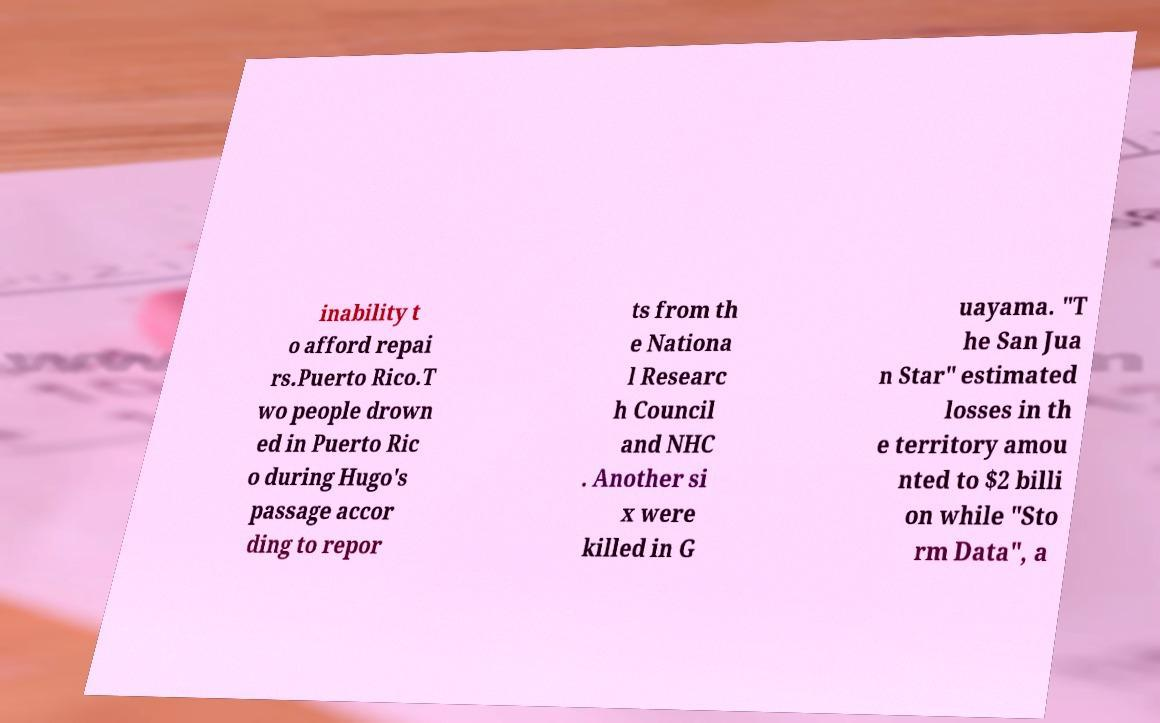Please read and relay the text visible in this image. What does it say? inability t o afford repai rs.Puerto Rico.T wo people drown ed in Puerto Ric o during Hugo's passage accor ding to repor ts from th e Nationa l Researc h Council and NHC . Another si x were killed in G uayama. "T he San Jua n Star" estimated losses in th e territory amou nted to $2 billi on while "Sto rm Data", a 